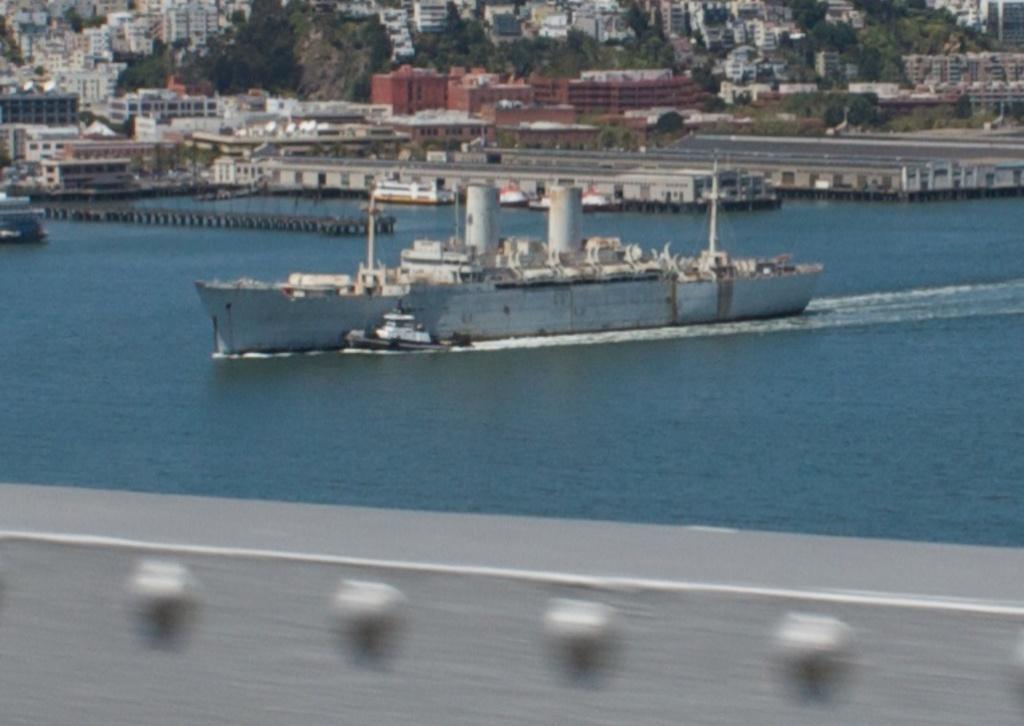How would you summarize this image in a sentence or two? In this image we can see a few ships on the water, there are some buildings, trees, poles and windows. 